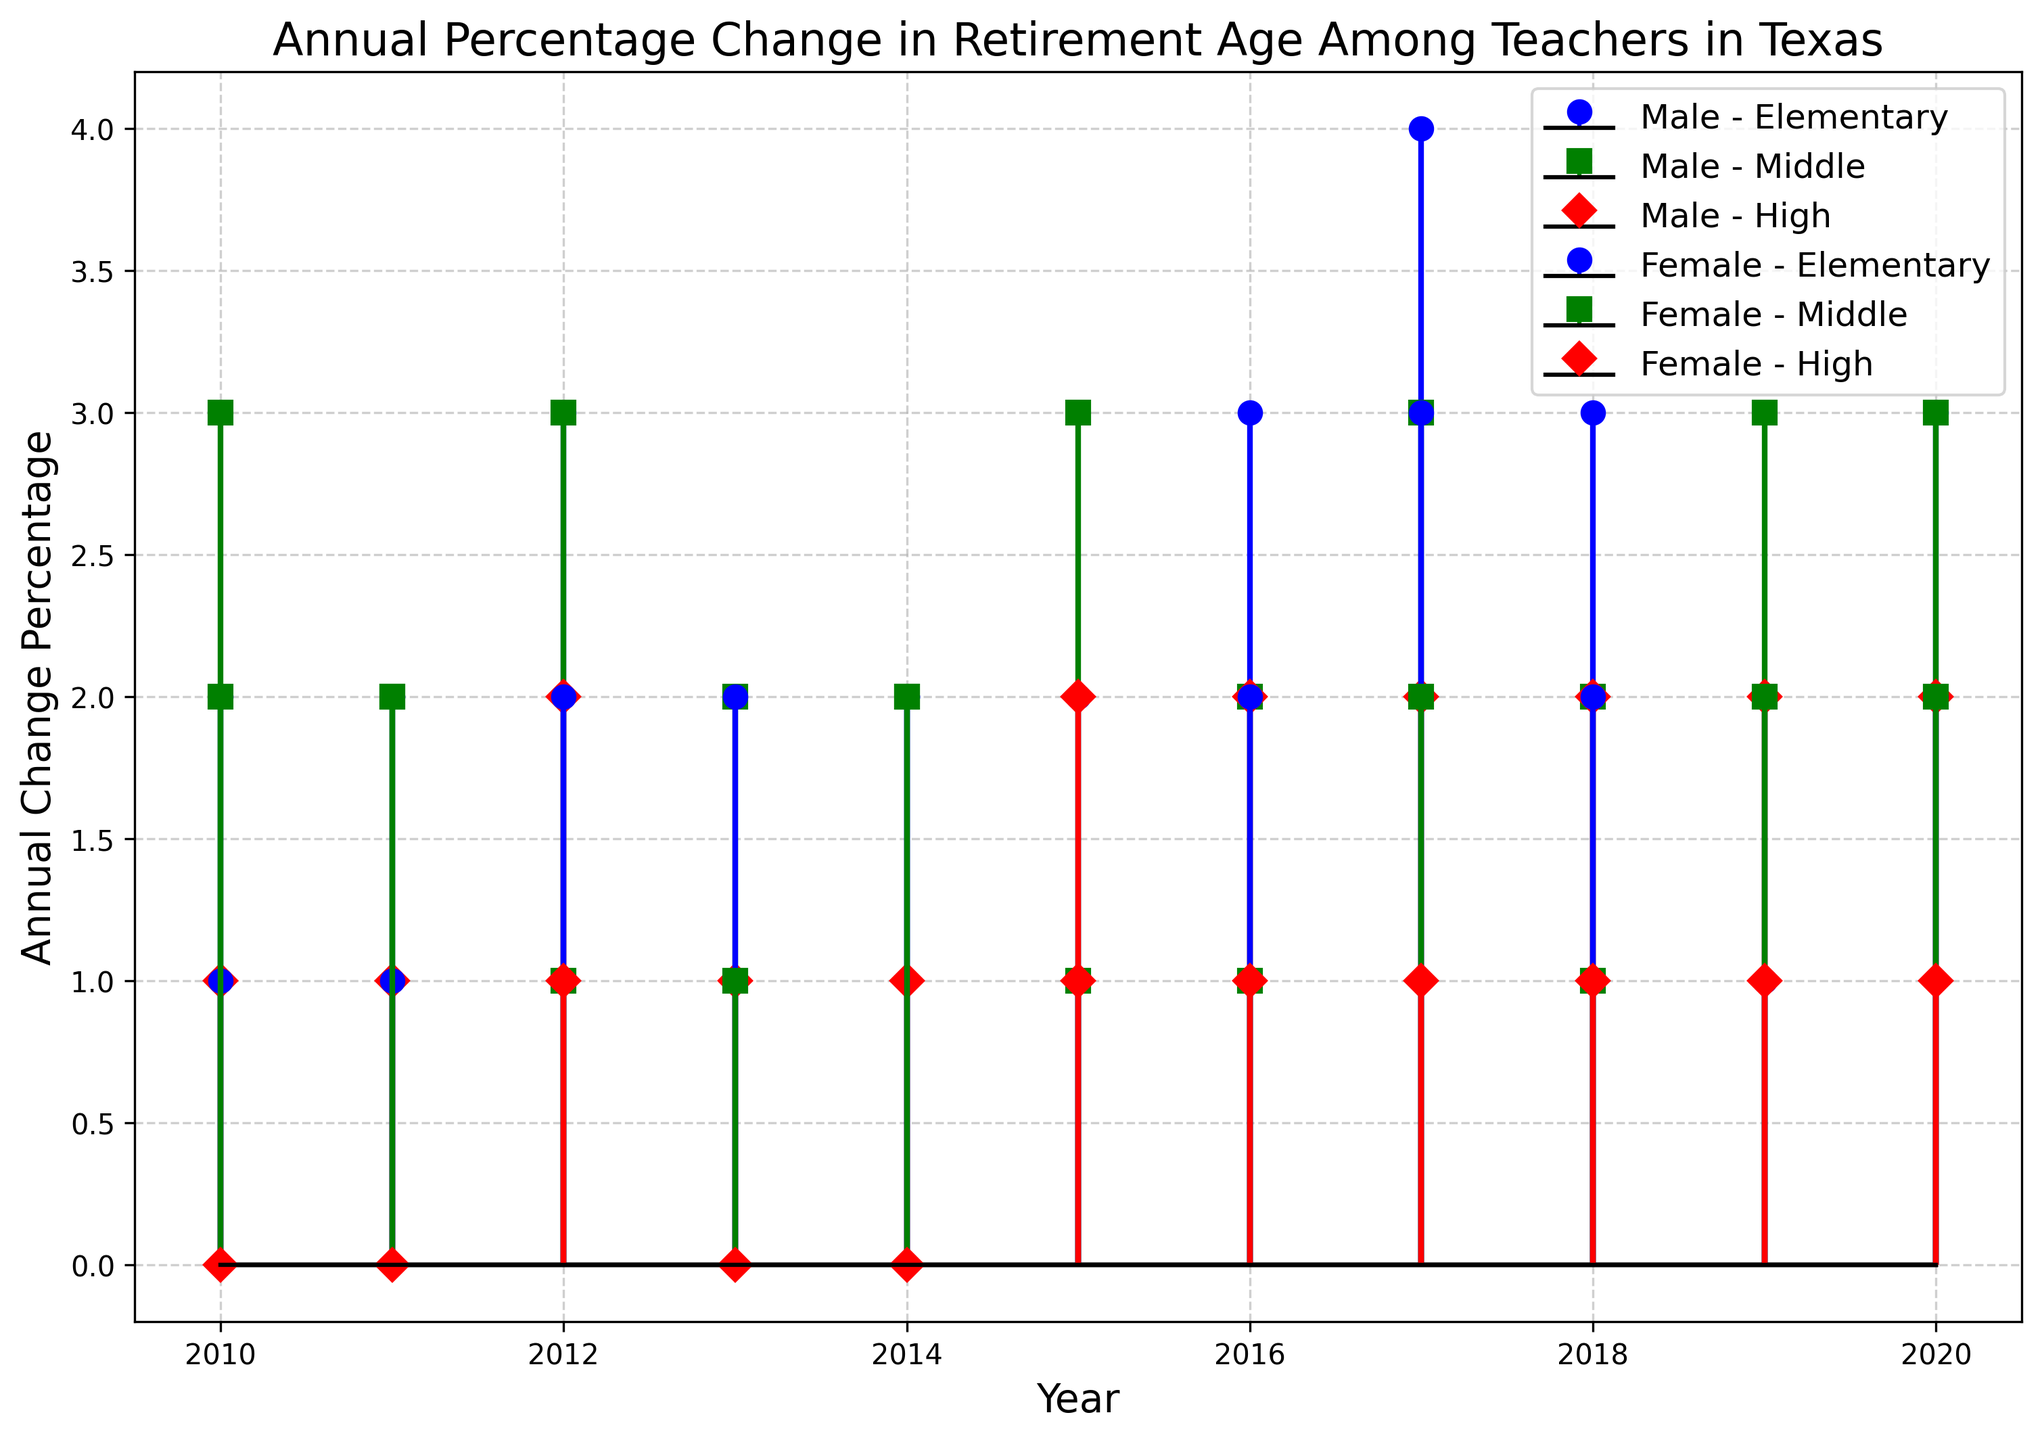Which gender had a higher annual percentage change in retirement age for Elementary teachers in 2015? Look at the stem plot markers for MALE - Elementary and FEMALE - Elementary in 2015, compare the heights. The male marker is higher.
Answer: Male During which year did Female Middle school teachers experience the lowest annual change percentage? Look at the plotting for FEMALE - Middle (likely represented by a unique marker and line style). Identify the year where this marker line is at its lowest point. The lowest point is in 2012 and 2013.
Answer: 2012, 2013 What is the average annual percentage change in retirement age for Male High school teachers from 2010 to 2020? Sum up the annual percentage changes for Male - High from 2010 to 2020 (1+1+2+1+1+2+2+2+2+2+2)/11. The sum is 2*11=22, so dividing by 11, the average is 2.
Answer: 2 Which teaching level had the highest maximum value of annual change percentage for Male teachers in the 10-year period? Compare the maximum values for Elementary, Middle, and High levels for males. Elementary reaches 4 in 2017, which is higher than the max for Middle (3) and High (2).
Answer: Elementary Did the annual percentage change for Female High school teachers ever exceed the annual percentage change for Male High school teachers within the time period? Compare the markers for FEMALE - High and MALE - High across all years. Female High school teachers' changes never exceed Male High school teachers' changes.
Answer: No What is the rate difference in the annual percentage change for Male Elementary and Female Elementary teachers in 2020? Find the annual change percentage for Male and Female Elementary teachers in 2020, subtract Female from Male (3-2).
Answer: 1 On average, which gender saw a more significant change in retirement age for Middle school teachers over the observed period? Sum the values for MALE - Middle (3+2+3+2+2+3+2+3+2+3) and FEMALE - Middle (2+2+1+1+2+1+1+2+1+2). Compare their averages. Male: 23/11 = 2.09, Female: 15/11 =  1.36
Answer: Male 